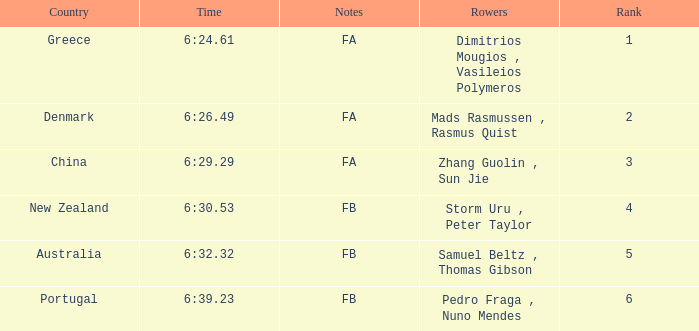What is the position of the time 6:3 1.0. 